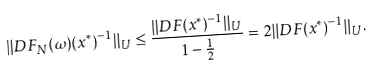<formula> <loc_0><loc_0><loc_500><loc_500>\| D F _ { N } ( \omega ) ( x ^ { * } ) ^ { - 1 } \| _ { U } \leq \frac { \| D F ( x ^ { * } ) ^ { - 1 } \| _ { U } } { 1 - \frac { 1 } { 2 } } = 2 \| D F ( x ^ { * } ) ^ { - 1 } \| _ { U } .</formula> 